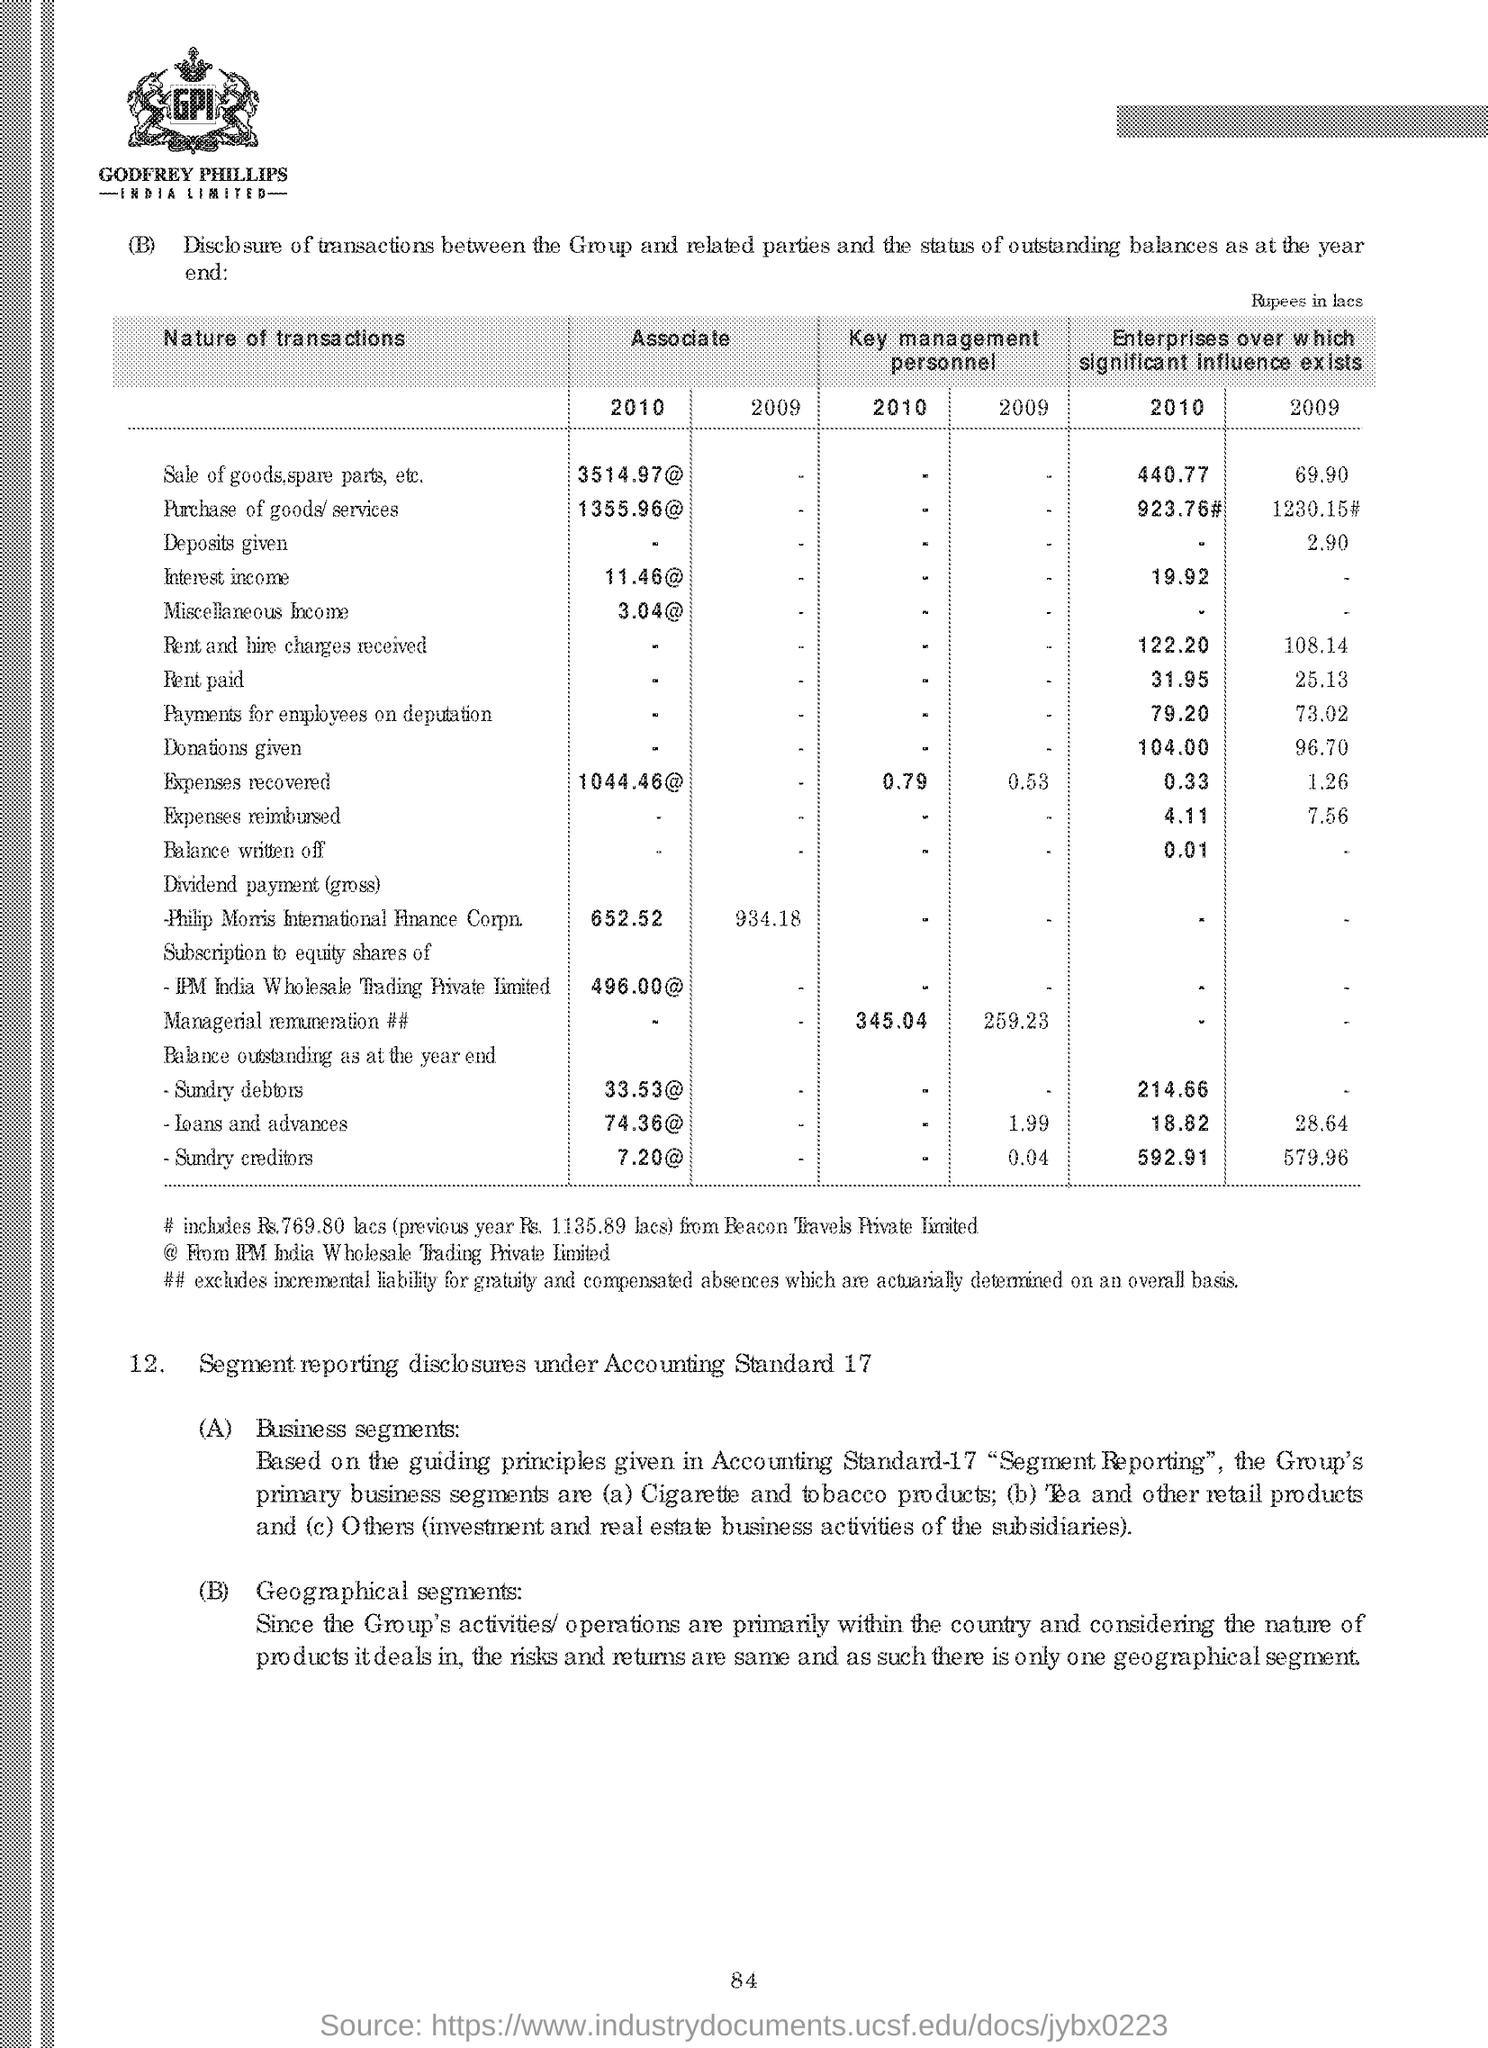Give some essential details in this illustration. The "Sale of goods, spare parts, etc." transaction had a more significant impact on enterprises in the year 2010 than in other years. The value of the associate fee for the year 2010 for a transaction related to the purchase of goods or services is 1355.96. The first transaction in the table is the sale of goods and spare parts, etc. IPM India Wholesale Trading Private Limited uses the symbol "@", which denotes a specific meaning within the company. 